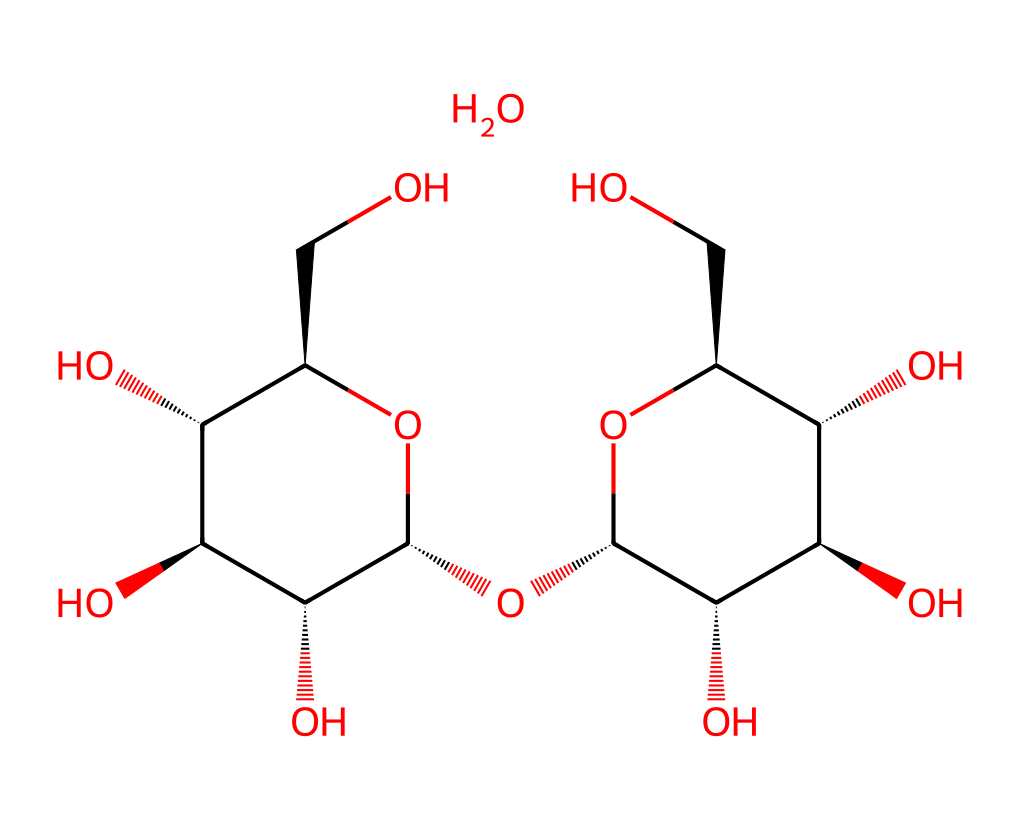What is the main component of this chemical structure? The chemical structure represents cornstarch, which is primarily composed of glucose units linked together in a specific arrangement forming a polysaccharide.
Answer: cornstarch How many carbon atoms are present in this structure? By analyzing the SMILES representation, each glucose unit contains six carbon atoms, and there are several glucose units included in the structure, totaling around 12 carbon atoms.
Answer: 12 How many hydroxyl (-OH) groups can you identify in this chemical? The structure exhibits multiple hydroxyl groups attached to the carbon skeleton of the glucose units, totaling over 10 hydroxyl groups in the whole molecule.
Answer: 10+ What type of non-Newtonian behavior does cornstarch in water exhibit? The suspension of cornstarch in water demonstrates shear-thickening behavior, meaning it becomes more viscous when subjected to stress or strain.
Answer: shear-thickening Why does the presence of amylose and amylopectin influence the viscosity properties of cornstarch? The mixture of these two forms of starch affects how the molecules interact with water; amylose provides gel-like properties while amylopectin contributes to the thickening effect, resulting in the unique viscosity behavior of the suspension.
Answer: viscosity properties What molecular feature contributes to the thickening property of cornstarch in water? The linear structure of amylose allows it to form a gel-like structure in the presence of water, while the branched amylopectin helps trap water, thus contributing to its thickening nature when agitated.
Answer: gel-like structure 